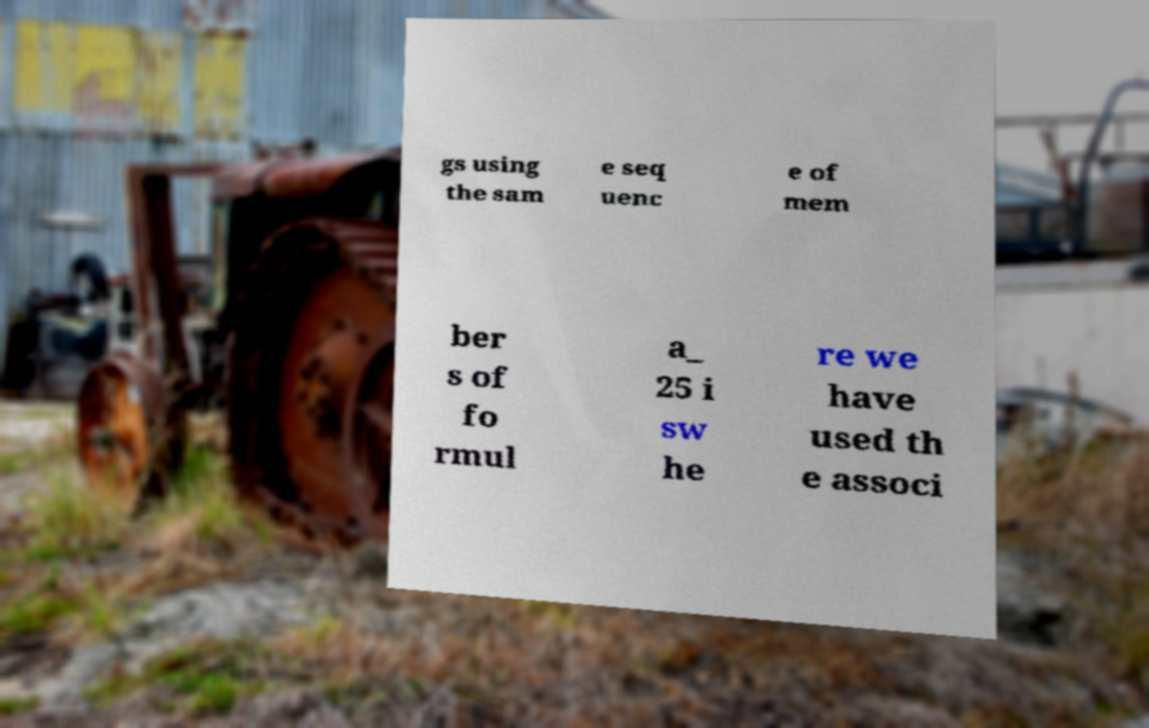Please read and relay the text visible in this image. What does it say? gs using the sam e seq uenc e of mem ber s of fo rmul a_ 25 i sw he re we have used th e associ 